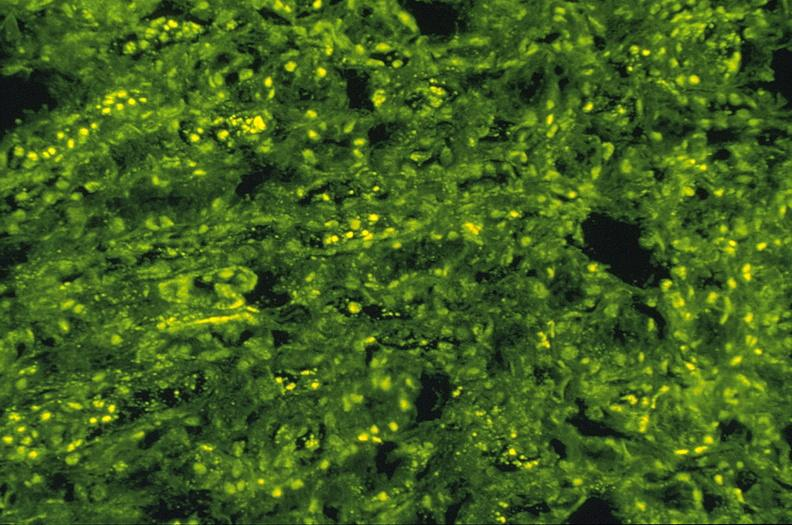does this image show sle iv, ana staining, kappa, 10x?
Answer the question using a single word or phrase. Yes 